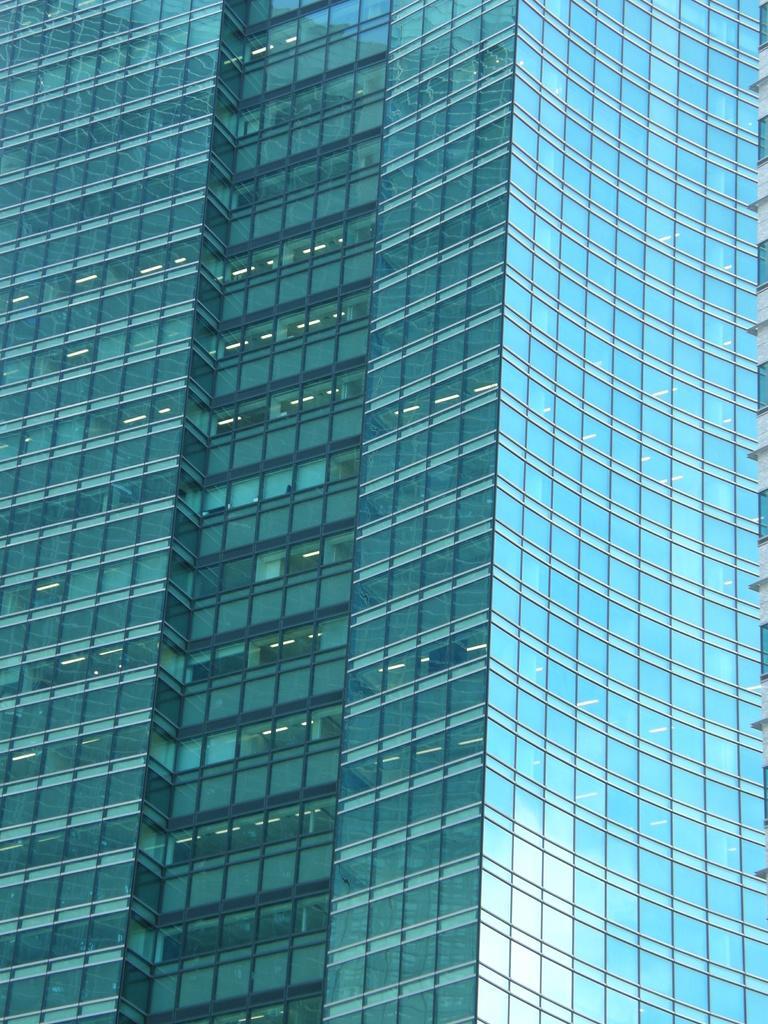Can you describe this image briefly? In this image we can see a building. 